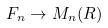<formula> <loc_0><loc_0><loc_500><loc_500>F _ { n } \rightarrow M _ { n } ( R )</formula> 